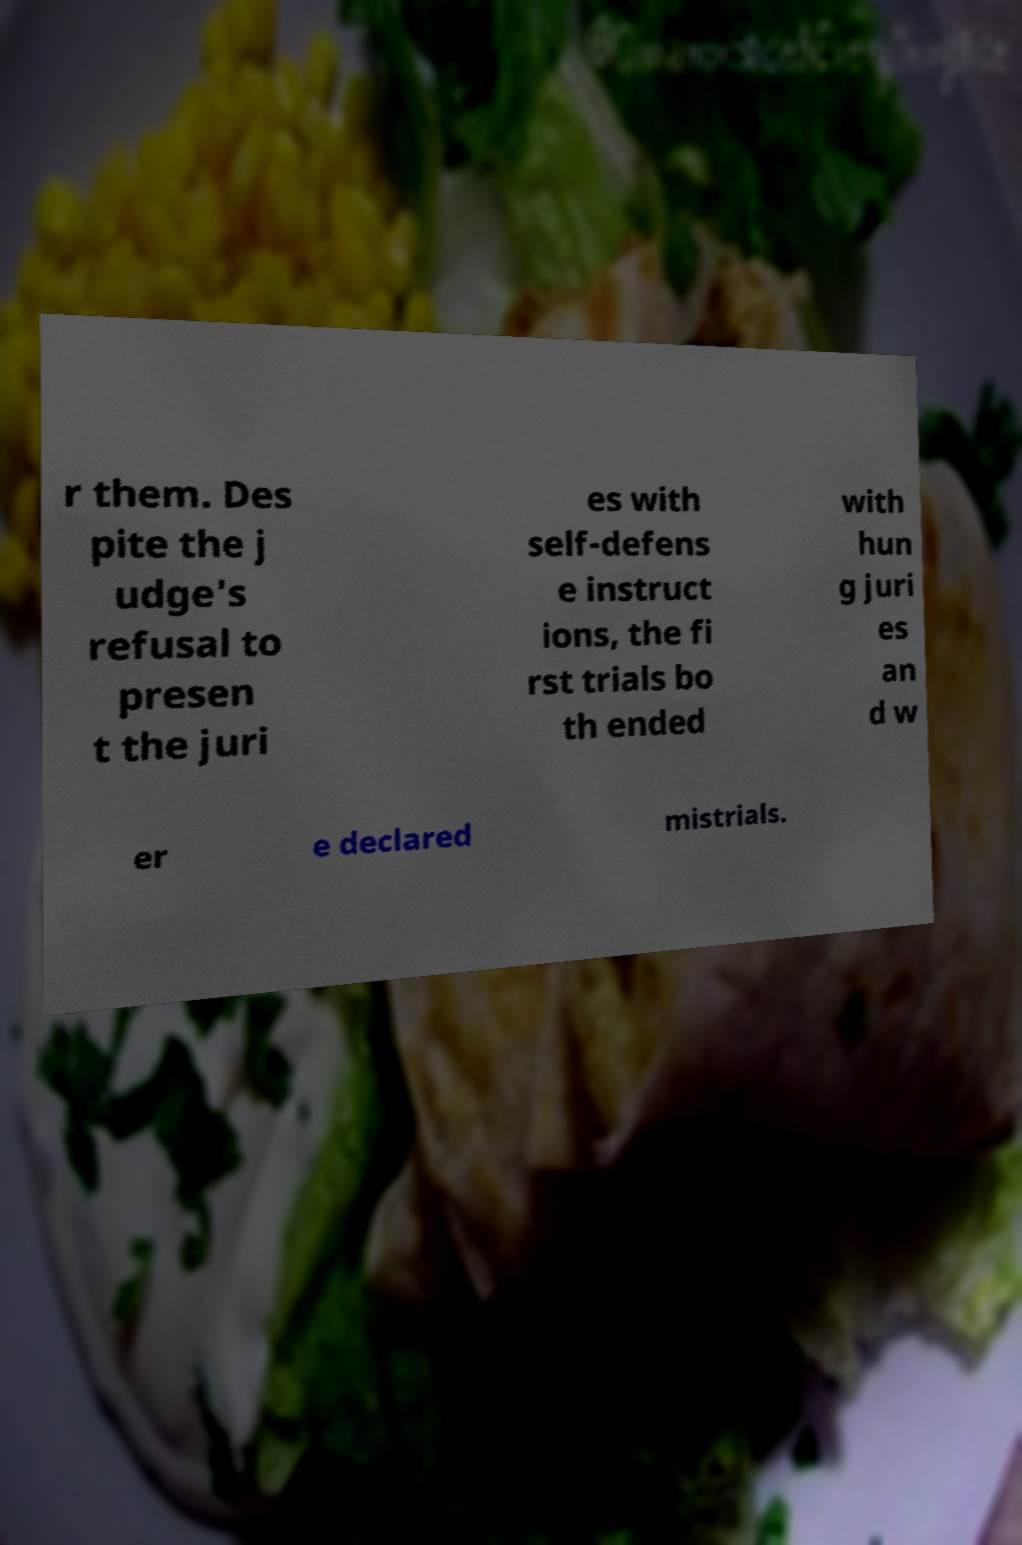I need the written content from this picture converted into text. Can you do that? r them. Des pite the j udge's refusal to presen t the juri es with self-defens e instruct ions, the fi rst trials bo th ended with hun g juri es an d w er e declared mistrials. 